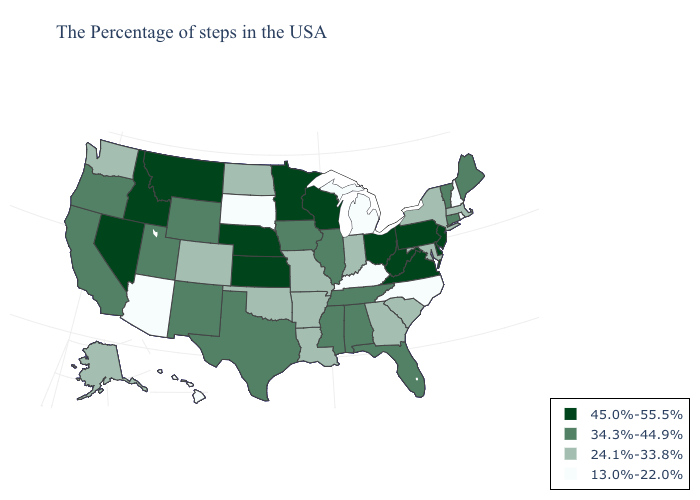What is the value of New Mexico?
Answer briefly. 34.3%-44.9%. Which states hav the highest value in the West?
Write a very short answer. Montana, Idaho, Nevada. Name the states that have a value in the range 34.3%-44.9%?
Short answer required. Maine, Vermont, Connecticut, Florida, Alabama, Tennessee, Illinois, Mississippi, Iowa, Texas, Wyoming, New Mexico, Utah, California, Oregon. Does New Hampshire have the lowest value in the USA?
Concise answer only. Yes. Name the states that have a value in the range 34.3%-44.9%?
Concise answer only. Maine, Vermont, Connecticut, Florida, Alabama, Tennessee, Illinois, Mississippi, Iowa, Texas, Wyoming, New Mexico, Utah, California, Oregon. Is the legend a continuous bar?
Give a very brief answer. No. What is the lowest value in the MidWest?
Give a very brief answer. 13.0%-22.0%. Is the legend a continuous bar?
Give a very brief answer. No. Which states hav the highest value in the Northeast?
Concise answer only. New Jersey, Pennsylvania. Does South Carolina have the same value as New York?
Write a very short answer. Yes. Does Arkansas have the lowest value in the USA?
Be succinct. No. How many symbols are there in the legend?
Keep it brief. 4. Does Alaska have the lowest value in the USA?
Short answer required. No. 